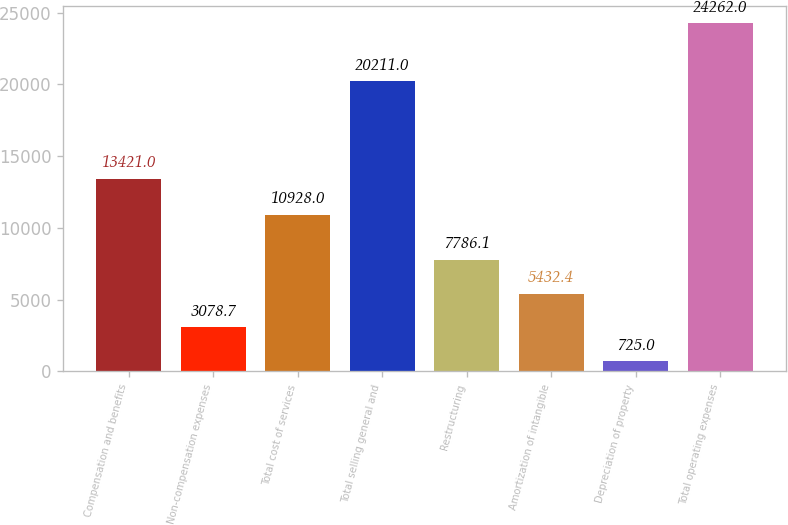Convert chart to OTSL. <chart><loc_0><loc_0><loc_500><loc_500><bar_chart><fcel>Compensation and benefits<fcel>Non-compensation expenses<fcel>Total cost of services<fcel>Total selling general and<fcel>Restructuring<fcel>Amortization of intangible<fcel>Depreciation of property<fcel>Total operating expenses<nl><fcel>13421<fcel>3078.7<fcel>10928<fcel>20211<fcel>7786.1<fcel>5432.4<fcel>725<fcel>24262<nl></chart> 